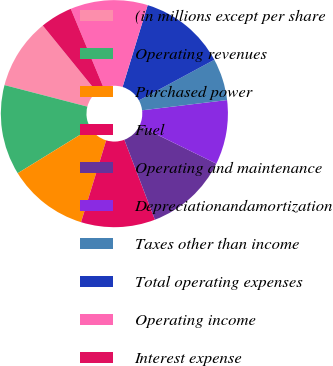<chart> <loc_0><loc_0><loc_500><loc_500><pie_chart><fcel>(in millions except per share<fcel>Operating revenues<fcel>Purchased power<fcel>Fuel<fcel>Operating and maintenance<fcel>Depreciationandamortization<fcel>Taxes other than income<fcel>Total operating expenses<fcel>Operating income<fcel>Interest expense<nl><fcel>10.09%<fcel>12.84%<fcel>11.47%<fcel>10.55%<fcel>11.93%<fcel>9.17%<fcel>5.96%<fcel>12.39%<fcel>11.01%<fcel>4.59%<nl></chart> 